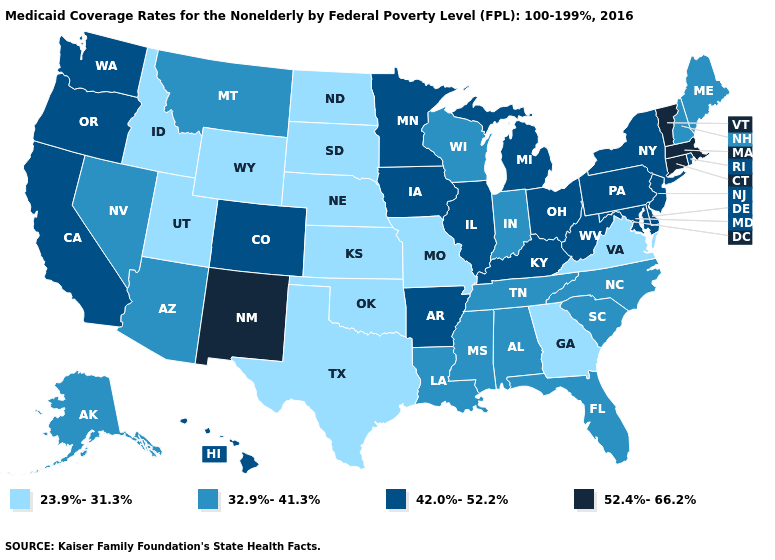Does Colorado have the lowest value in the West?
Keep it brief. No. Name the states that have a value in the range 42.0%-52.2%?
Keep it brief. Arkansas, California, Colorado, Delaware, Hawaii, Illinois, Iowa, Kentucky, Maryland, Michigan, Minnesota, New Jersey, New York, Ohio, Oregon, Pennsylvania, Rhode Island, Washington, West Virginia. Which states have the lowest value in the MidWest?
Answer briefly. Kansas, Missouri, Nebraska, North Dakota, South Dakota. What is the value of West Virginia?
Quick response, please. 42.0%-52.2%. What is the value of New Jersey?
Write a very short answer. 42.0%-52.2%. Does Washington have the lowest value in the West?
Concise answer only. No. Name the states that have a value in the range 52.4%-66.2%?
Write a very short answer. Connecticut, Massachusetts, New Mexico, Vermont. What is the value of Hawaii?
Concise answer only. 42.0%-52.2%. What is the value of Virginia?
Be succinct. 23.9%-31.3%. Does Mississippi have the lowest value in the USA?
Answer briefly. No. What is the lowest value in states that border New Mexico?
Answer briefly. 23.9%-31.3%. Name the states that have a value in the range 23.9%-31.3%?
Keep it brief. Georgia, Idaho, Kansas, Missouri, Nebraska, North Dakota, Oklahoma, South Dakota, Texas, Utah, Virginia, Wyoming. What is the value of Washington?
Quick response, please. 42.0%-52.2%. Name the states that have a value in the range 23.9%-31.3%?
Give a very brief answer. Georgia, Idaho, Kansas, Missouri, Nebraska, North Dakota, Oklahoma, South Dakota, Texas, Utah, Virginia, Wyoming. 